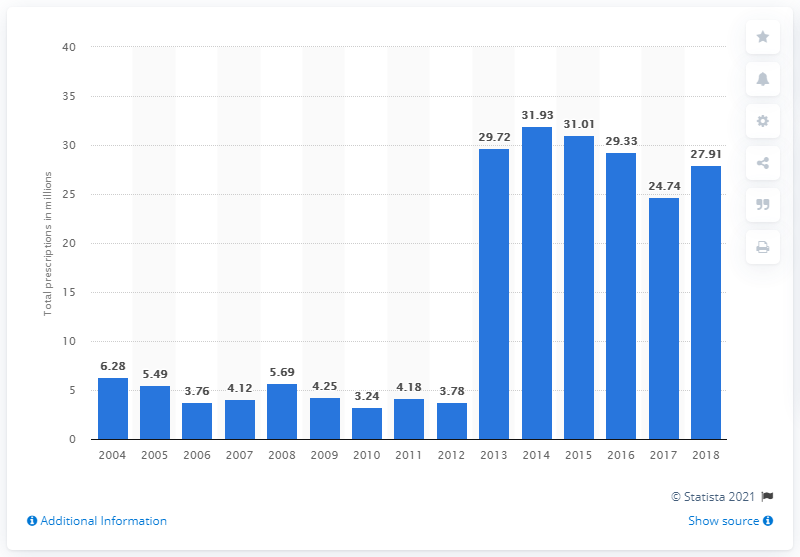List a handful of essential elements in this visual. In 2018, there were 27,910 prescriptions for acetaminophen filled in the United States. 